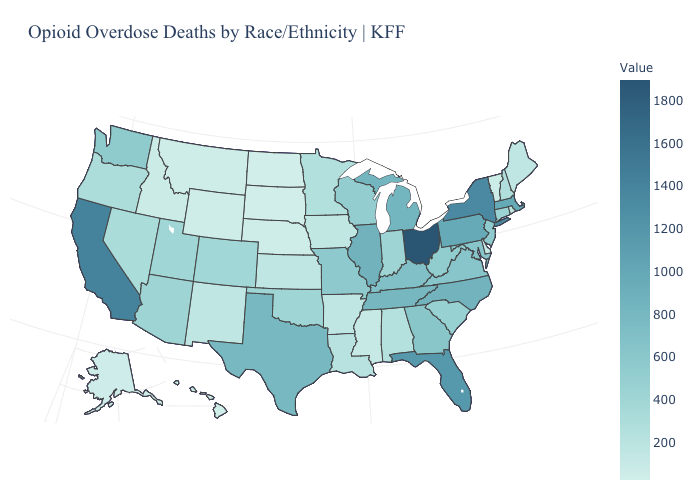Does Ohio have the highest value in the USA?
Quick response, please. Yes. Does Oregon have the highest value in the West?
Concise answer only. No. Among the states that border Nebraska , does Missouri have the lowest value?
Concise answer only. No. Is the legend a continuous bar?
Answer briefly. Yes. Which states have the lowest value in the USA?
Write a very short answer. North Dakota. Among the states that border Wisconsin , does Michigan have the highest value?
Write a very short answer. No. 